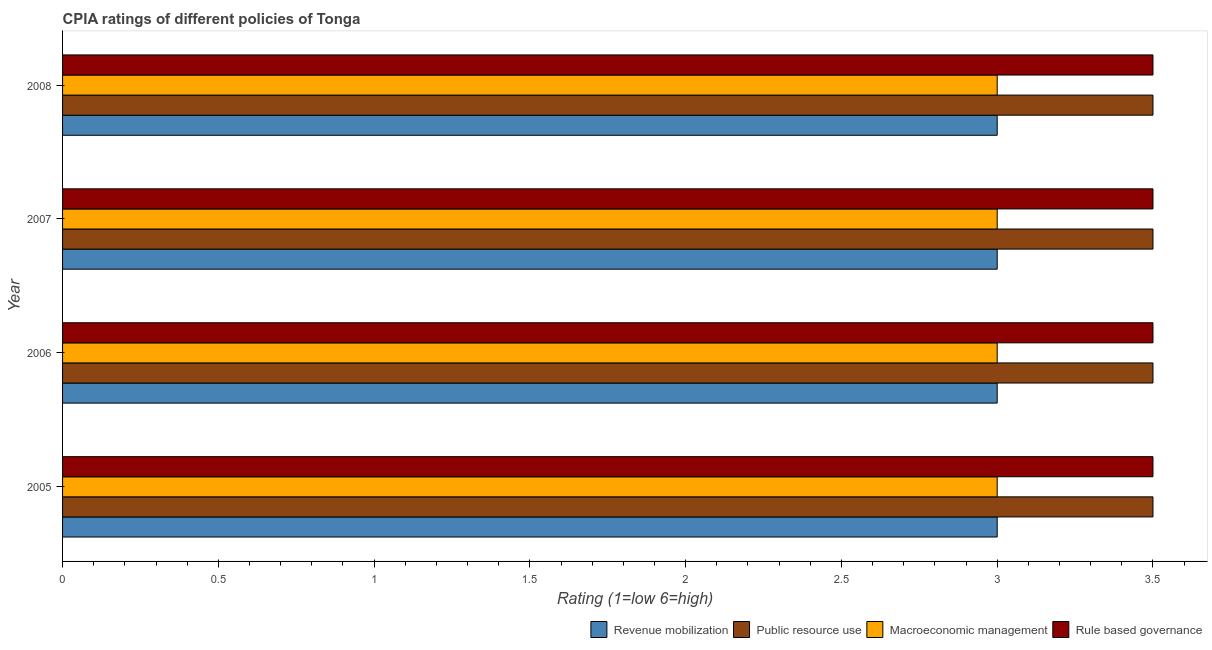Are the number of bars on each tick of the Y-axis equal?
Provide a succinct answer. Yes. How many bars are there on the 1st tick from the top?
Provide a succinct answer. 4. Across all years, what is the maximum cpia rating of rule based governance?
Your response must be concise. 3.5. Across all years, what is the minimum cpia rating of macroeconomic management?
Provide a succinct answer. 3. In which year was the cpia rating of macroeconomic management minimum?
Keep it short and to the point. 2005. What is the total cpia rating of revenue mobilization in the graph?
Make the answer very short. 12. What is the difference between the cpia rating of revenue mobilization in 2007 and that in 2008?
Provide a short and direct response. 0. What is the ratio of the cpia rating of public resource use in 2006 to that in 2008?
Make the answer very short. 1. Is the difference between the cpia rating of public resource use in 2005 and 2006 greater than the difference between the cpia rating of rule based governance in 2005 and 2006?
Your answer should be very brief. No. What is the difference between the highest and the lowest cpia rating of public resource use?
Offer a very short reply. 0. Is the sum of the cpia rating of revenue mobilization in 2007 and 2008 greater than the maximum cpia rating of public resource use across all years?
Your answer should be very brief. Yes. What does the 4th bar from the top in 2007 represents?
Give a very brief answer. Revenue mobilization. What does the 4th bar from the bottom in 2006 represents?
Keep it short and to the point. Rule based governance. How many bars are there?
Keep it short and to the point. 16. Are all the bars in the graph horizontal?
Provide a succinct answer. Yes. What is the difference between two consecutive major ticks on the X-axis?
Offer a terse response. 0.5. Are the values on the major ticks of X-axis written in scientific E-notation?
Your response must be concise. No. Does the graph contain any zero values?
Your response must be concise. No. Does the graph contain grids?
Keep it short and to the point. No. Where does the legend appear in the graph?
Make the answer very short. Bottom right. How many legend labels are there?
Provide a short and direct response. 4. What is the title of the graph?
Give a very brief answer. CPIA ratings of different policies of Tonga. What is the label or title of the X-axis?
Give a very brief answer. Rating (1=low 6=high). What is the Rating (1=low 6=high) of Public resource use in 2006?
Your answer should be compact. 3.5. What is the Rating (1=low 6=high) in Macroeconomic management in 2006?
Your answer should be compact. 3. What is the Rating (1=low 6=high) in Public resource use in 2007?
Provide a succinct answer. 3.5. What is the Rating (1=low 6=high) in Macroeconomic management in 2007?
Keep it short and to the point. 3. What is the Rating (1=low 6=high) in Rule based governance in 2007?
Provide a succinct answer. 3.5. What is the Rating (1=low 6=high) in Macroeconomic management in 2008?
Keep it short and to the point. 3. What is the Rating (1=low 6=high) in Rule based governance in 2008?
Ensure brevity in your answer.  3.5. Across all years, what is the maximum Rating (1=low 6=high) of Revenue mobilization?
Give a very brief answer. 3. Across all years, what is the maximum Rating (1=low 6=high) of Public resource use?
Give a very brief answer. 3.5. Across all years, what is the maximum Rating (1=low 6=high) of Macroeconomic management?
Ensure brevity in your answer.  3. Across all years, what is the minimum Rating (1=low 6=high) of Revenue mobilization?
Provide a succinct answer. 3. Across all years, what is the minimum Rating (1=low 6=high) of Macroeconomic management?
Make the answer very short. 3. Across all years, what is the minimum Rating (1=low 6=high) of Rule based governance?
Keep it short and to the point. 3.5. What is the total Rating (1=low 6=high) in Revenue mobilization in the graph?
Provide a succinct answer. 12. What is the total Rating (1=low 6=high) of Public resource use in the graph?
Make the answer very short. 14. What is the total Rating (1=low 6=high) in Macroeconomic management in the graph?
Give a very brief answer. 12. What is the total Rating (1=low 6=high) in Rule based governance in the graph?
Ensure brevity in your answer.  14. What is the difference between the Rating (1=low 6=high) in Public resource use in 2005 and that in 2006?
Provide a succinct answer. 0. What is the difference between the Rating (1=low 6=high) of Macroeconomic management in 2005 and that in 2006?
Provide a short and direct response. 0. What is the difference between the Rating (1=low 6=high) in Rule based governance in 2005 and that in 2006?
Provide a short and direct response. 0. What is the difference between the Rating (1=low 6=high) in Macroeconomic management in 2005 and that in 2007?
Provide a short and direct response. 0. What is the difference between the Rating (1=low 6=high) in Revenue mobilization in 2005 and that in 2008?
Provide a short and direct response. 0. What is the difference between the Rating (1=low 6=high) in Public resource use in 2005 and that in 2008?
Offer a very short reply. 0. What is the difference between the Rating (1=low 6=high) of Macroeconomic management in 2005 and that in 2008?
Your answer should be very brief. 0. What is the difference between the Rating (1=low 6=high) in Rule based governance in 2005 and that in 2008?
Your response must be concise. 0. What is the difference between the Rating (1=low 6=high) of Revenue mobilization in 2006 and that in 2007?
Your response must be concise. 0. What is the difference between the Rating (1=low 6=high) of Revenue mobilization in 2006 and that in 2008?
Offer a very short reply. 0. What is the difference between the Rating (1=low 6=high) of Public resource use in 2006 and that in 2008?
Offer a terse response. 0. What is the difference between the Rating (1=low 6=high) of Rule based governance in 2006 and that in 2008?
Make the answer very short. 0. What is the difference between the Rating (1=low 6=high) in Revenue mobilization in 2007 and that in 2008?
Make the answer very short. 0. What is the difference between the Rating (1=low 6=high) in Rule based governance in 2007 and that in 2008?
Your response must be concise. 0. What is the difference between the Rating (1=low 6=high) of Public resource use in 2005 and the Rating (1=low 6=high) of Rule based governance in 2006?
Offer a terse response. 0. What is the difference between the Rating (1=low 6=high) in Macroeconomic management in 2005 and the Rating (1=low 6=high) in Rule based governance in 2006?
Provide a short and direct response. -0.5. What is the difference between the Rating (1=low 6=high) of Revenue mobilization in 2005 and the Rating (1=low 6=high) of Public resource use in 2007?
Your response must be concise. -0.5. What is the difference between the Rating (1=low 6=high) in Revenue mobilization in 2005 and the Rating (1=low 6=high) in Rule based governance in 2007?
Make the answer very short. -0.5. What is the difference between the Rating (1=low 6=high) in Public resource use in 2005 and the Rating (1=low 6=high) in Rule based governance in 2007?
Give a very brief answer. 0. What is the difference between the Rating (1=low 6=high) in Macroeconomic management in 2005 and the Rating (1=low 6=high) in Rule based governance in 2007?
Give a very brief answer. -0.5. What is the difference between the Rating (1=low 6=high) of Revenue mobilization in 2005 and the Rating (1=low 6=high) of Macroeconomic management in 2008?
Ensure brevity in your answer.  0. What is the difference between the Rating (1=low 6=high) in Revenue mobilization in 2005 and the Rating (1=low 6=high) in Rule based governance in 2008?
Provide a short and direct response. -0.5. What is the difference between the Rating (1=low 6=high) of Public resource use in 2005 and the Rating (1=low 6=high) of Rule based governance in 2008?
Your answer should be compact. 0. What is the difference between the Rating (1=low 6=high) of Revenue mobilization in 2006 and the Rating (1=low 6=high) of Macroeconomic management in 2007?
Provide a short and direct response. 0. What is the difference between the Rating (1=low 6=high) of Public resource use in 2006 and the Rating (1=low 6=high) of Macroeconomic management in 2007?
Provide a succinct answer. 0.5. What is the difference between the Rating (1=low 6=high) of Macroeconomic management in 2006 and the Rating (1=low 6=high) of Rule based governance in 2007?
Offer a very short reply. -0.5. What is the difference between the Rating (1=low 6=high) of Revenue mobilization in 2006 and the Rating (1=low 6=high) of Macroeconomic management in 2008?
Provide a short and direct response. 0. What is the difference between the Rating (1=low 6=high) in Public resource use in 2006 and the Rating (1=low 6=high) in Rule based governance in 2008?
Provide a short and direct response. 0. What is the difference between the Rating (1=low 6=high) in Revenue mobilization in 2007 and the Rating (1=low 6=high) in Public resource use in 2008?
Keep it short and to the point. -0.5. What is the difference between the Rating (1=low 6=high) of Revenue mobilization in 2007 and the Rating (1=low 6=high) of Macroeconomic management in 2008?
Offer a terse response. 0. What is the difference between the Rating (1=low 6=high) of Public resource use in 2007 and the Rating (1=low 6=high) of Rule based governance in 2008?
Offer a terse response. 0. What is the average Rating (1=low 6=high) of Public resource use per year?
Provide a succinct answer. 3.5. In the year 2005, what is the difference between the Rating (1=low 6=high) in Public resource use and Rating (1=low 6=high) in Macroeconomic management?
Provide a short and direct response. 0.5. In the year 2005, what is the difference between the Rating (1=low 6=high) of Public resource use and Rating (1=low 6=high) of Rule based governance?
Provide a succinct answer. 0. In the year 2006, what is the difference between the Rating (1=low 6=high) of Revenue mobilization and Rating (1=low 6=high) of Macroeconomic management?
Provide a short and direct response. 0. In the year 2006, what is the difference between the Rating (1=low 6=high) of Revenue mobilization and Rating (1=low 6=high) of Rule based governance?
Your response must be concise. -0.5. In the year 2006, what is the difference between the Rating (1=low 6=high) of Public resource use and Rating (1=low 6=high) of Macroeconomic management?
Your answer should be compact. 0.5. In the year 2006, what is the difference between the Rating (1=low 6=high) in Macroeconomic management and Rating (1=low 6=high) in Rule based governance?
Ensure brevity in your answer.  -0.5. In the year 2007, what is the difference between the Rating (1=low 6=high) in Public resource use and Rating (1=low 6=high) in Rule based governance?
Your response must be concise. 0. In the year 2008, what is the difference between the Rating (1=low 6=high) in Revenue mobilization and Rating (1=low 6=high) in Rule based governance?
Your answer should be very brief. -0.5. In the year 2008, what is the difference between the Rating (1=low 6=high) of Public resource use and Rating (1=low 6=high) of Rule based governance?
Provide a succinct answer. 0. What is the ratio of the Rating (1=low 6=high) in Revenue mobilization in 2005 to that in 2006?
Your response must be concise. 1. What is the ratio of the Rating (1=low 6=high) of Rule based governance in 2005 to that in 2006?
Offer a terse response. 1. What is the ratio of the Rating (1=low 6=high) in Macroeconomic management in 2005 to that in 2007?
Your answer should be very brief. 1. What is the ratio of the Rating (1=low 6=high) in Public resource use in 2005 to that in 2008?
Give a very brief answer. 1. What is the ratio of the Rating (1=low 6=high) of Rule based governance in 2005 to that in 2008?
Offer a very short reply. 1. What is the ratio of the Rating (1=low 6=high) in Revenue mobilization in 2006 to that in 2007?
Give a very brief answer. 1. What is the ratio of the Rating (1=low 6=high) of Public resource use in 2006 to that in 2007?
Provide a short and direct response. 1. What is the ratio of the Rating (1=low 6=high) of Rule based governance in 2006 to that in 2007?
Keep it short and to the point. 1. What is the ratio of the Rating (1=low 6=high) of Revenue mobilization in 2006 to that in 2008?
Give a very brief answer. 1. What is the ratio of the Rating (1=low 6=high) of Macroeconomic management in 2006 to that in 2008?
Offer a terse response. 1. What is the ratio of the Rating (1=low 6=high) in Revenue mobilization in 2007 to that in 2008?
Make the answer very short. 1. What is the ratio of the Rating (1=low 6=high) of Public resource use in 2007 to that in 2008?
Ensure brevity in your answer.  1. What is the ratio of the Rating (1=low 6=high) of Macroeconomic management in 2007 to that in 2008?
Ensure brevity in your answer.  1. What is the ratio of the Rating (1=low 6=high) of Rule based governance in 2007 to that in 2008?
Your answer should be very brief. 1. What is the difference between the highest and the second highest Rating (1=low 6=high) of Revenue mobilization?
Your response must be concise. 0. What is the difference between the highest and the second highest Rating (1=low 6=high) of Macroeconomic management?
Your answer should be very brief. 0. What is the difference between the highest and the lowest Rating (1=low 6=high) of Macroeconomic management?
Offer a very short reply. 0. What is the difference between the highest and the lowest Rating (1=low 6=high) in Rule based governance?
Make the answer very short. 0. 